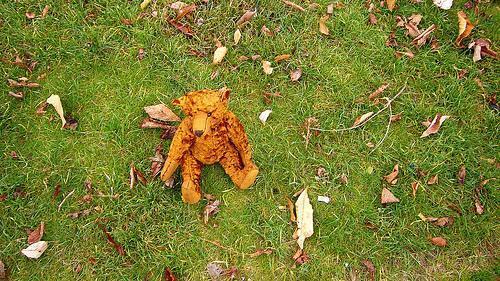How many teddy bears are in the picture?
Give a very brief answer. 1. 